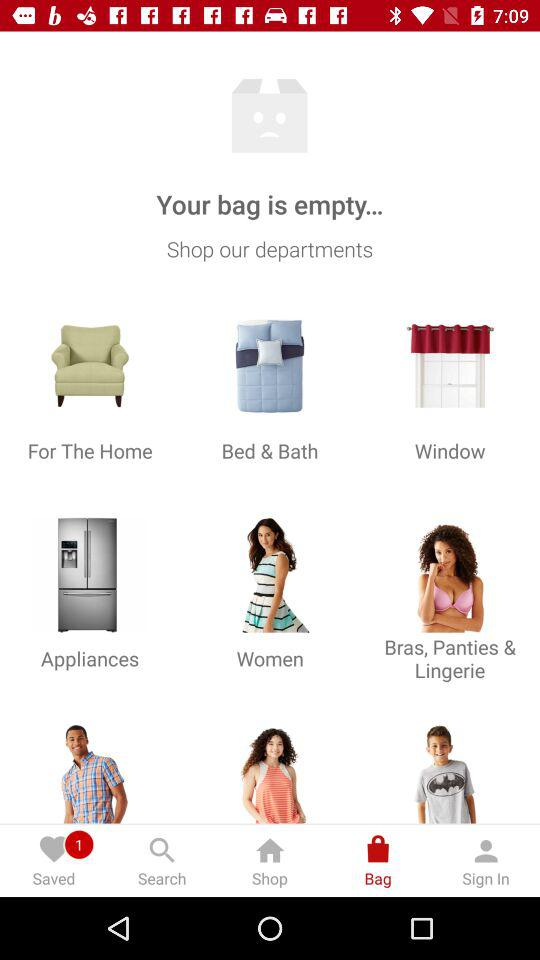What are the different categories available to choose from for shopping? The different categories available are: "For The Home", "Bed & Bath", "Window", "Appliances", "Women", and "Bras, Panties & Lingerie". 